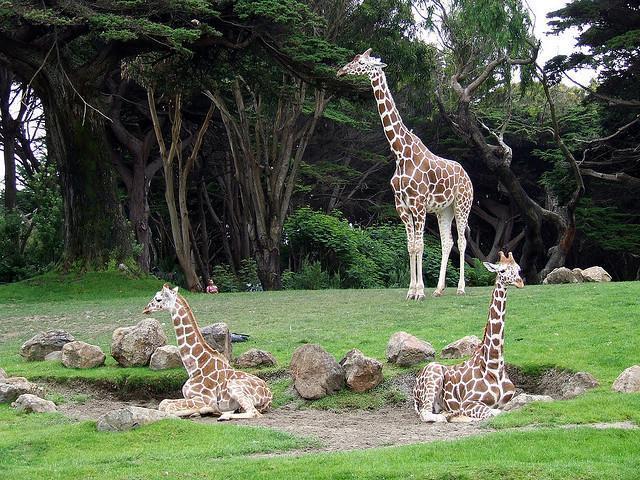How many giraffes are sitting?
Give a very brief answer. 2. How many giraffes are there?
Give a very brief answer. 3. How many orange boats are there?
Give a very brief answer. 0. 